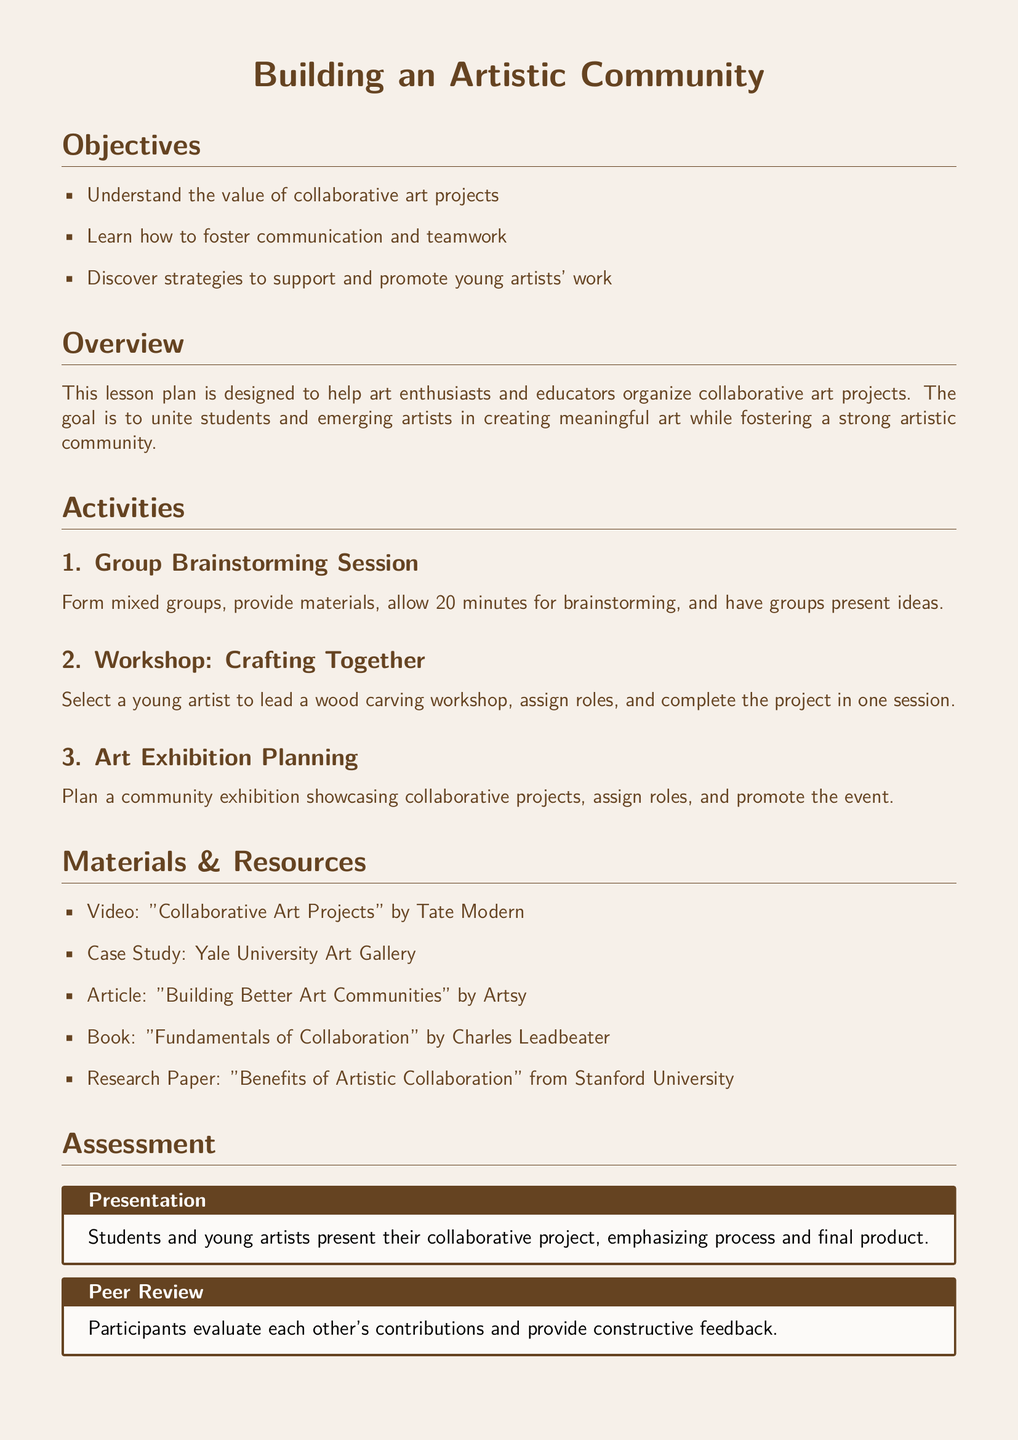what is the main goal of the lesson plan? The main goal is to unite students and emerging artists in creating meaningful art while fostering a strong artistic community.
Answer: to unite students and emerging artists in creating meaningful art while fostering a strong artistic community who leads the wood carving workshop? The lesson plan mentions selecting a young artist to lead the workshop.
Answer: a young artist how long is the group brainstorming session? The document states that 20 minutes is allowed for brainstorming in groups.
Answer: 20 minutes what publication is referenced as a resource for understanding collaboration? The referenced publication is "Fundamentals of Collaboration" by Charles Leadbeater.
Answer: Fundamentals of Collaboration which university contributed to the research paper on artistic collaboration? The research paper is from Stanford University, which contributed to the document's resources.
Answer: Stanford University what type of assessment involves constructive feedback? The document refers to the assessment type that involves evaluating each other's contributions and providing constructive feedback.
Answer: Peer Review what is the first activity mentioned in the lesson plan? The first activity described in the lesson plan is a group brainstorming session.
Answer: Group Brainstorming Session how many objectives are outlined in the document? The lesson plan outlines three objectives related to collaborative art projects.
Answer: three 